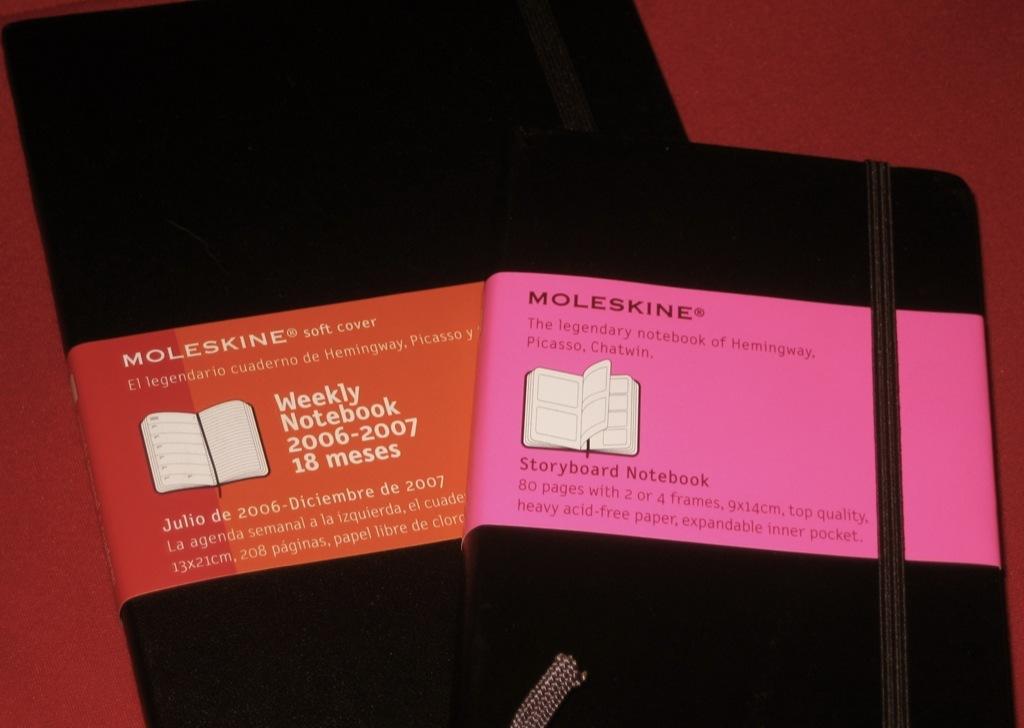What years is the weekly notebook made for?
Ensure brevity in your answer.  2006-2007. What is the name of the pink color book?
Provide a short and direct response. Moleskine. 